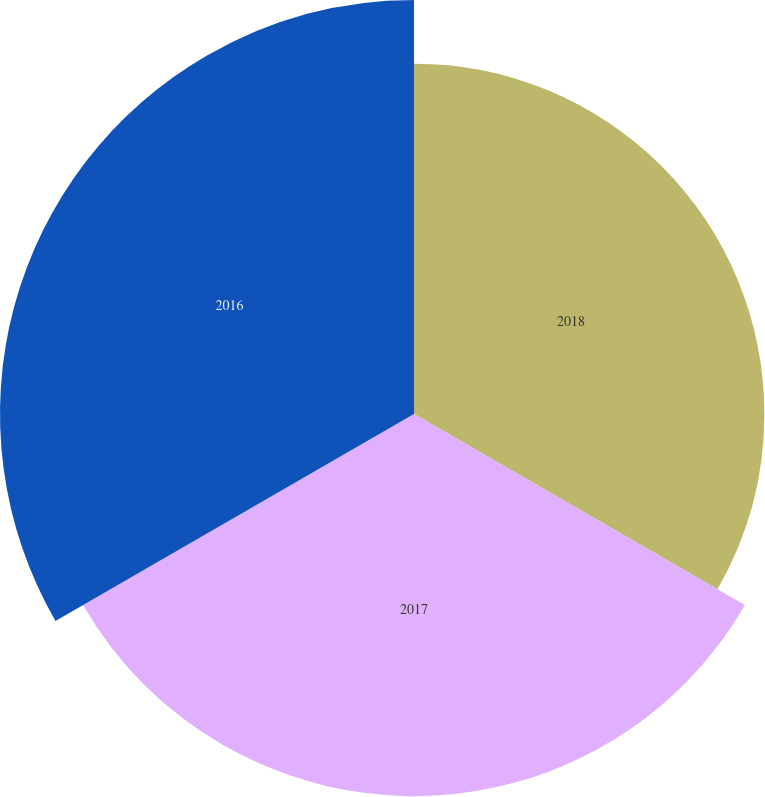Convert chart to OTSL. <chart><loc_0><loc_0><loc_500><loc_500><pie_chart><fcel>2018<fcel>2017<fcel>2016<nl><fcel>30.56%<fcel>33.33%<fcel>36.11%<nl></chart> 